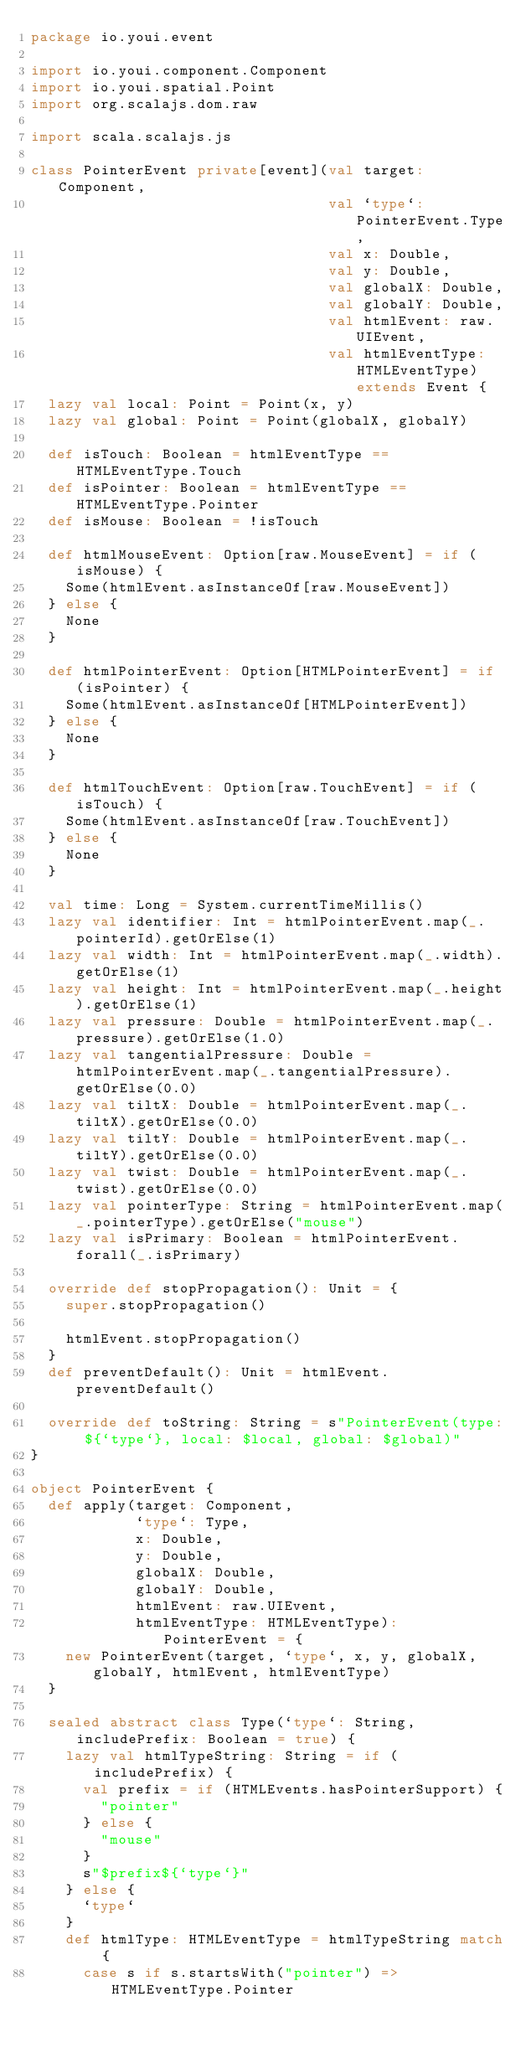<code> <loc_0><loc_0><loc_500><loc_500><_Scala_>package io.youi.event

import io.youi.component.Component
import io.youi.spatial.Point
import org.scalajs.dom.raw

import scala.scalajs.js

class PointerEvent private[event](val target: Component,
                                  val `type`: PointerEvent.Type,
                                  val x: Double,
                                  val y: Double,
                                  val globalX: Double,
                                  val globalY: Double,
                                  val htmlEvent: raw.UIEvent,
                                  val htmlEventType: HTMLEventType) extends Event {
  lazy val local: Point = Point(x, y)
  lazy val global: Point = Point(globalX, globalY)

  def isTouch: Boolean = htmlEventType == HTMLEventType.Touch
  def isPointer: Boolean = htmlEventType == HTMLEventType.Pointer
  def isMouse: Boolean = !isTouch

  def htmlMouseEvent: Option[raw.MouseEvent] = if (isMouse) {
    Some(htmlEvent.asInstanceOf[raw.MouseEvent])
  } else {
    None
  }

  def htmlPointerEvent: Option[HTMLPointerEvent] = if (isPointer) {
    Some(htmlEvent.asInstanceOf[HTMLPointerEvent])
  } else {
    None
  }

  def htmlTouchEvent: Option[raw.TouchEvent] = if (isTouch) {
    Some(htmlEvent.asInstanceOf[raw.TouchEvent])
  } else {
    None
  }

  val time: Long = System.currentTimeMillis()
  lazy val identifier: Int = htmlPointerEvent.map(_.pointerId).getOrElse(1)
  lazy val width: Int = htmlPointerEvent.map(_.width).getOrElse(1)
  lazy val height: Int = htmlPointerEvent.map(_.height).getOrElse(1)
  lazy val pressure: Double = htmlPointerEvent.map(_.pressure).getOrElse(1.0)
  lazy val tangentialPressure: Double = htmlPointerEvent.map(_.tangentialPressure).getOrElse(0.0)
  lazy val tiltX: Double = htmlPointerEvent.map(_.tiltX).getOrElse(0.0)
  lazy val tiltY: Double = htmlPointerEvent.map(_.tiltY).getOrElse(0.0)
  lazy val twist: Double = htmlPointerEvent.map(_.twist).getOrElse(0.0)
  lazy val pointerType: String = htmlPointerEvent.map(_.pointerType).getOrElse("mouse")
  lazy val isPrimary: Boolean = htmlPointerEvent.forall(_.isPrimary)

  override def stopPropagation(): Unit = {
    super.stopPropagation()

    htmlEvent.stopPropagation()
  }
  def preventDefault(): Unit = htmlEvent.preventDefault()

  override def toString: String = s"PointerEvent(type: ${`type`}, local: $local, global: $global)"
}

object PointerEvent {
  def apply(target: Component,
            `type`: Type,
            x: Double,
            y: Double,
            globalX: Double,
            globalY: Double,
            htmlEvent: raw.UIEvent,
            htmlEventType: HTMLEventType): PointerEvent = {
    new PointerEvent(target, `type`, x, y, globalX, globalY, htmlEvent, htmlEventType)
  }

  sealed abstract class Type(`type`: String, includePrefix: Boolean = true) {
    lazy val htmlTypeString: String = if (includePrefix) {
      val prefix = if (HTMLEvents.hasPointerSupport) {
        "pointer"
      } else {
        "mouse"
      }
      s"$prefix${`type`}"
    } else {
      `type`
    }
    def htmlType: HTMLEventType = htmlTypeString match {
      case s if s.startsWith("pointer") => HTMLEventType.Pointer</code> 